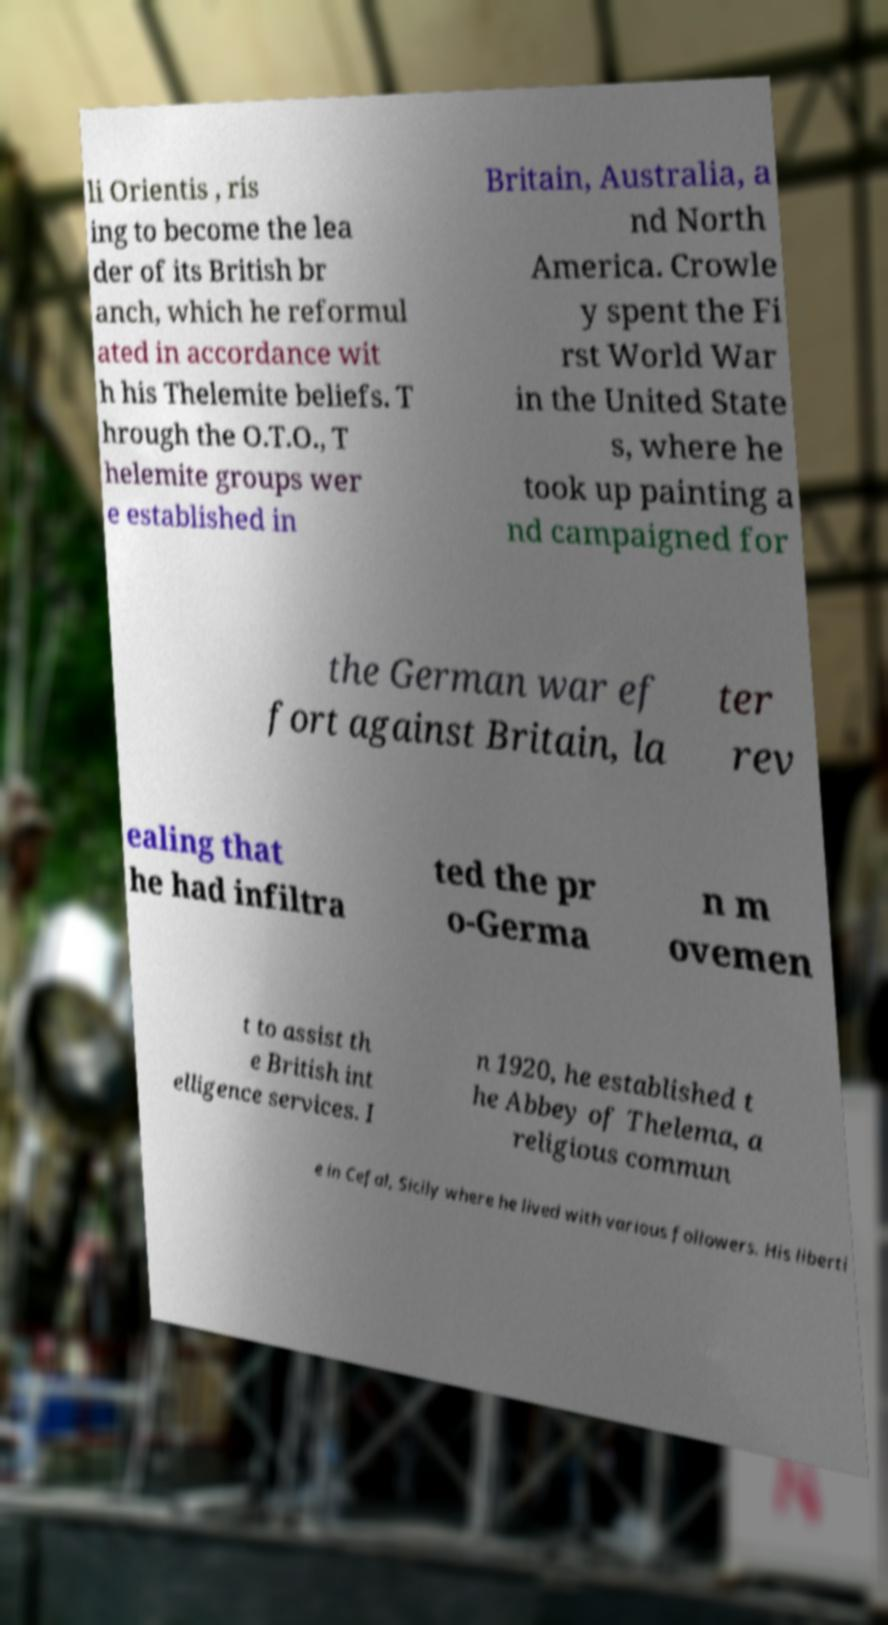For documentation purposes, I need the text within this image transcribed. Could you provide that? li Orientis , ris ing to become the lea der of its British br anch, which he reformul ated in accordance wit h his Thelemite beliefs. T hrough the O.T.O., T helemite groups wer e established in Britain, Australia, a nd North America. Crowle y spent the Fi rst World War in the United State s, where he took up painting a nd campaigned for the German war ef fort against Britain, la ter rev ealing that he had infiltra ted the pr o-Germa n m ovemen t to assist th e British int elligence services. I n 1920, he established t he Abbey of Thelema, a religious commun e in Cefal, Sicily where he lived with various followers. His liberti 